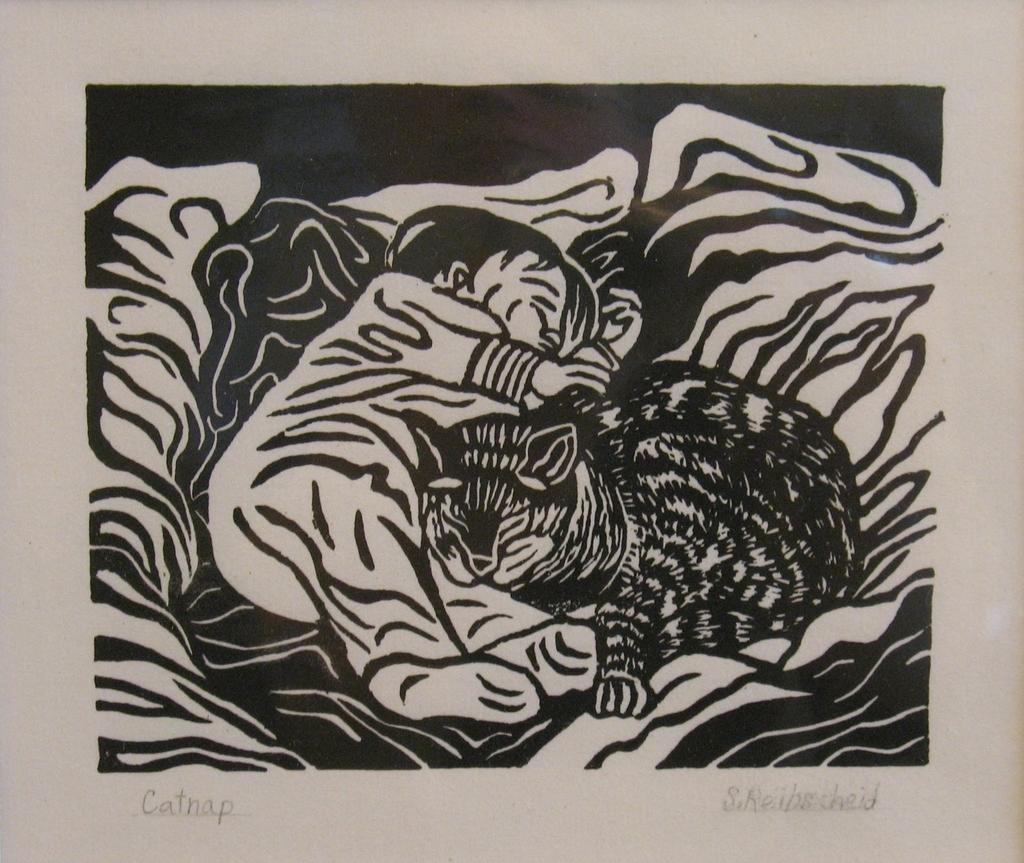What type of image is depicted in the drawing? The image is a black and white drawing. What is the main subject of the drawing? There is a baby lying in the drawing. Is there any other living creature present in the drawing? Yes, there is a cat near the baby in the drawing. Are there any words or letters written on the image? Yes, there is text written on the image. What decision does the monkey make in the drawing? There is no monkey present in the drawing, so no decision can be made by a monkey. Can you describe the bubble that the baby is holding in the drawing? There is no bubble present in the drawing; it is a black and white drawing with a baby and a cat. 